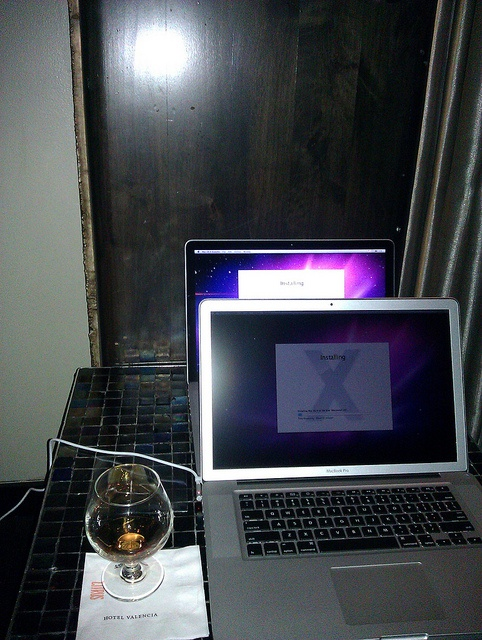Describe the objects in this image and their specific colors. I can see laptop in darkgreen, black, gray, navy, and blue tones, keyboard in darkgreen, black, gray, and purple tones, laptop in darkgreen, black, white, navy, and gray tones, and wine glass in darkgreen, black, lightgray, gray, and darkgray tones in this image. 